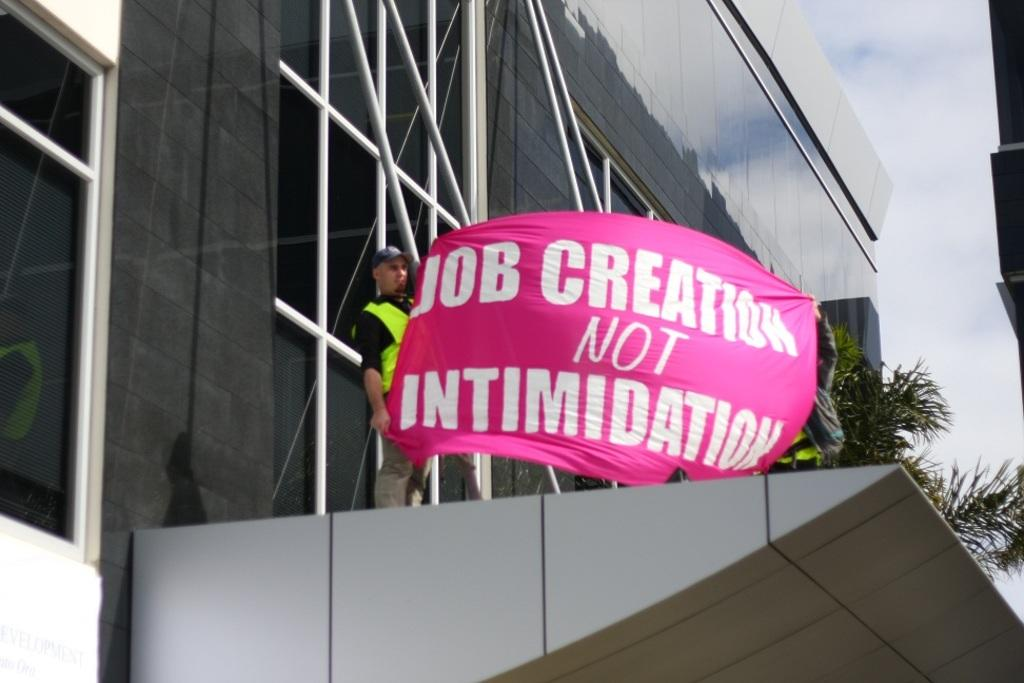What is the main subject in the center of the image? There is a building in the center of the image. What are the people on the building doing? Two people are standing on the building and holding a banner. What can be seen in the background of the image? There is a tree and the sky visible in the background of the image. What type of quartz can be seen on the banner held by the people? There is no quartz present on the banner held by the people; it is a banner with text or a design. Can you describe the body language of the doll in the image? There is no doll present in the image. 